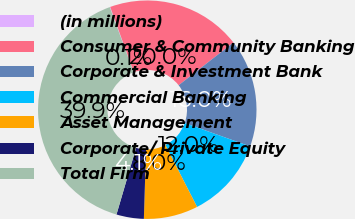<chart> <loc_0><loc_0><loc_500><loc_500><pie_chart><fcel>(in millions)<fcel>Consumer & Community Banking<fcel>Corporate & Investment Bank<fcel>Commercial Banking<fcel>Asset Management<fcel>Corporate/ Private Equity<fcel>Total Firm<nl><fcel>0.07%<fcel>19.97%<fcel>15.99%<fcel>12.01%<fcel>8.03%<fcel>4.05%<fcel>39.87%<nl></chart> 